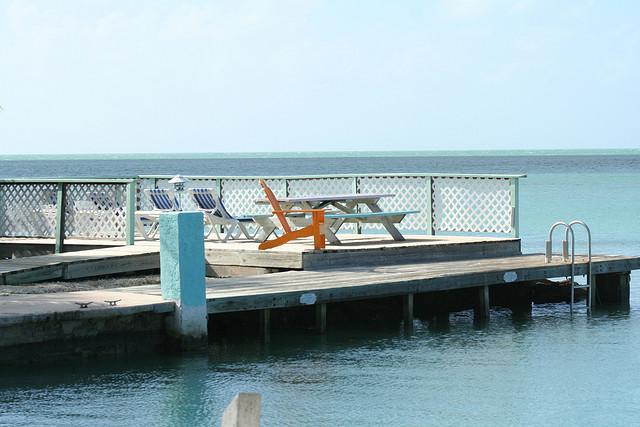What color is the chair that stands out in the picture?
Short answer required. Orange. How many people can sit here?
Quick response, please. 11. Can you go swimming at this location?
Give a very brief answer. Yes. 